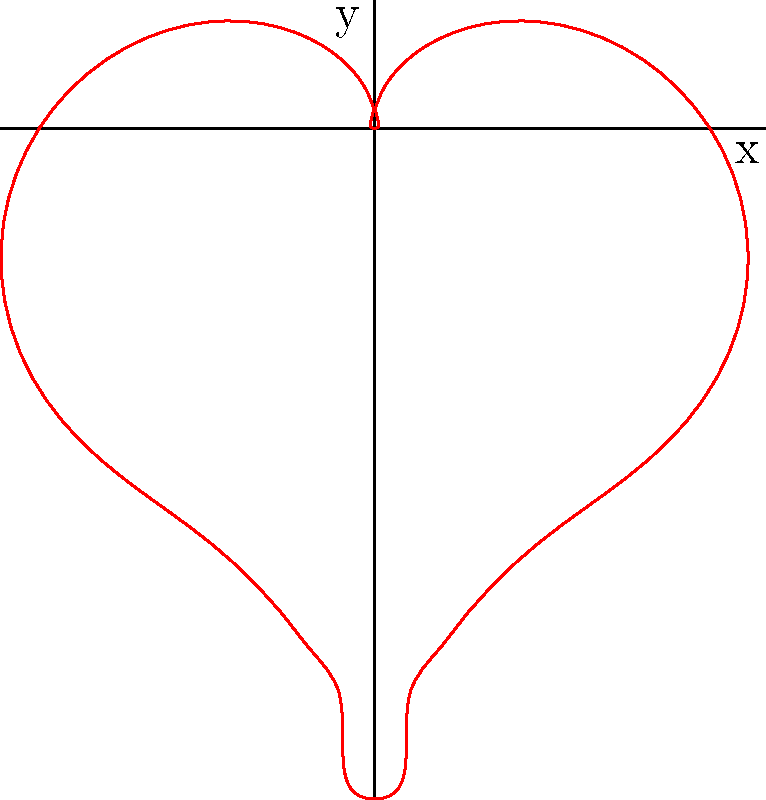Yo, lyrical maestro! Check this heart-shaped curve in polar coordinates. It's defined by the equation:

$$r = 2 - 2\sin(\theta) + \frac{\sin(\theta)\sqrt{|\cos(\theta)|}}{\sin(\theta)+1.4}$$

What's the maximum value of $r$ in this equation? Spit it like Big Pun would! Alright, let's break this down like we're crafting verses:

1) First, observe that the equation has three terms:
   $$2 - 2\sin(\theta) + \frac{\sin(\theta)\sqrt{|\cos(\theta)|}}{\sin(\theta)+1.4}$$

2) The first term is constant: 2
3) The second term, $-2\sin(\theta)$, ranges from -2 to 2
4) The third term is always positive (due to absolute value and square root), but small

5) The maximum value of $r$ will occur when:
   - $\sin(\theta)$ is at its minimum (-1)
   - $\cos(\theta)$ is at its maximum (1)

6) This happens when $\theta = \frac{3\pi}{2}$

7) Plugging in $\theta = \frac{3\pi}{2}$:
   $$r = 2 - 2(-1) + \frac{(-1)\sqrt{|\cos(\frac{3\pi}{2})|}}{\sin(\frac{3\pi}{2})+1.4}$$

8) Simplify:
   $$r = 2 + 2 + \frac{(-1)\sqrt{|0|}}{-1+1.4} = 4 + 0 = 4$$

Therefore, the maximum value of $r$ is 4.
Answer: 4 